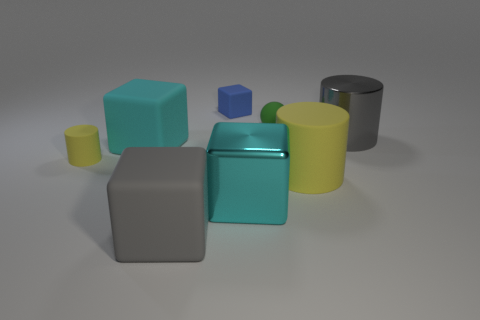Is the number of small matte cubes that are to the right of the big gray shiny cylinder less than the number of big yellow rubber cylinders that are to the left of the tiny yellow rubber object?
Keep it short and to the point. No. Are the tiny ball and the big gray thing that is to the right of the gray matte object made of the same material?
Your response must be concise. No. Is there anything else that has the same material as the big gray cube?
Make the answer very short. Yes. Are there more blue rubber objects than small blue spheres?
Make the answer very short. Yes. There is a big matte thing that is to the left of the big rubber block that is in front of the big cyan thing that is on the left side of the blue cube; what shape is it?
Offer a terse response. Cube. Do the large cyan object that is in front of the tiny yellow rubber cylinder and the cube behind the shiny cylinder have the same material?
Ensure brevity in your answer.  No. There is a small green thing that is made of the same material as the blue thing; what is its shape?
Your response must be concise. Sphere. Is there any other thing that is the same color as the shiny cylinder?
Your response must be concise. Yes. How many large green things are there?
Ensure brevity in your answer.  0. What material is the yellow cylinder that is on the right side of the cyan thing in front of the small yellow object?
Your response must be concise. Rubber. 